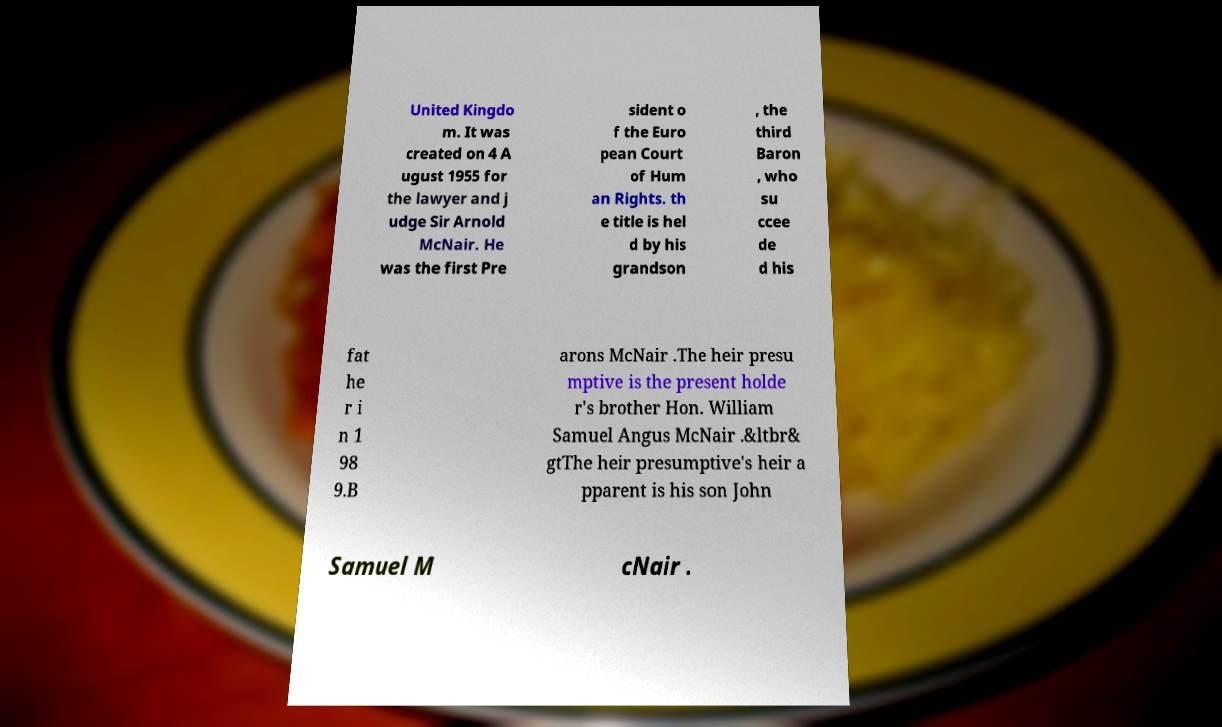What messages or text are displayed in this image? I need them in a readable, typed format. United Kingdo m. It was created on 4 A ugust 1955 for the lawyer and j udge Sir Arnold McNair. He was the first Pre sident o f the Euro pean Court of Hum an Rights. th e title is hel d by his grandson , the third Baron , who su ccee de d his fat he r i n 1 98 9.B arons McNair .The heir presu mptive is the present holde r's brother Hon. William Samuel Angus McNair .&ltbr& gtThe heir presumptive's heir a pparent is his son John Samuel M cNair . 